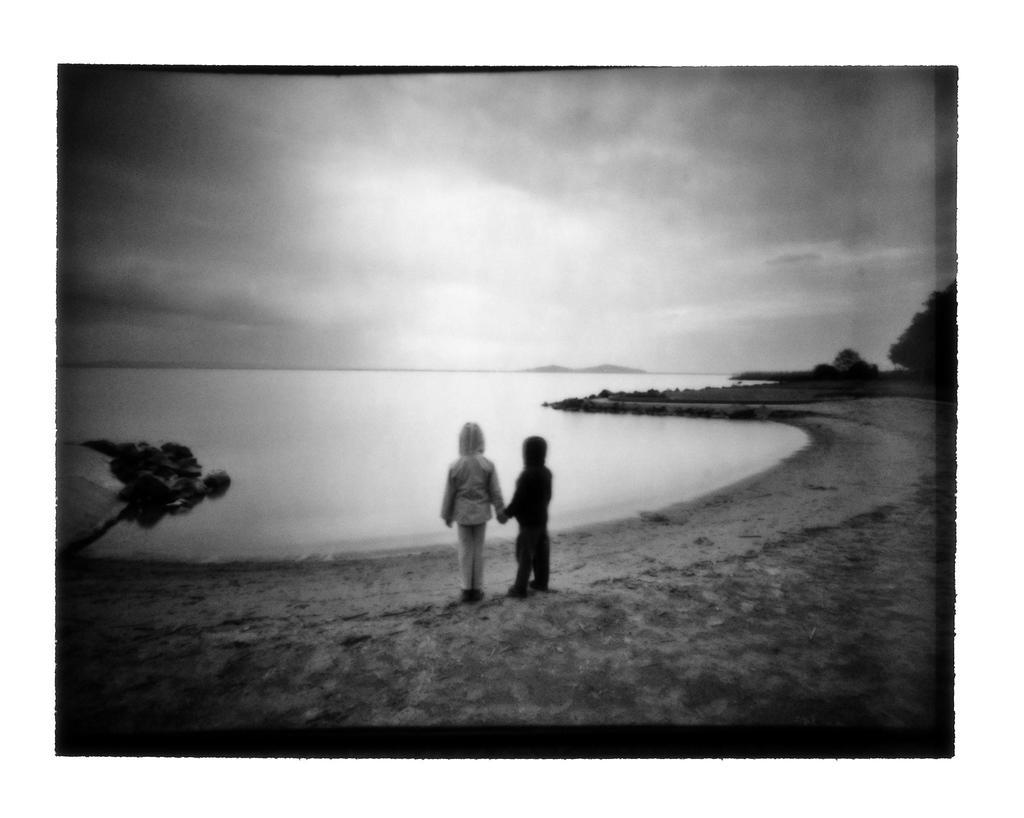What type of natural environment is depicted in the image? There is a sea in the image, which indicates a coastal or beach setting. What other natural elements can be seen in the image? There are many trees in the image, suggesting a forested area near the sea. How many people are present in the image? There are two persons standing at the seashore in the image. What is the condition of the sky in the image? The sky is slightly cloudy in the image. What type of flowers are growing near the earth in the image? There are no flowers or earth mentioned in the image; it features a sea, trees, and two persons at the seashore. 